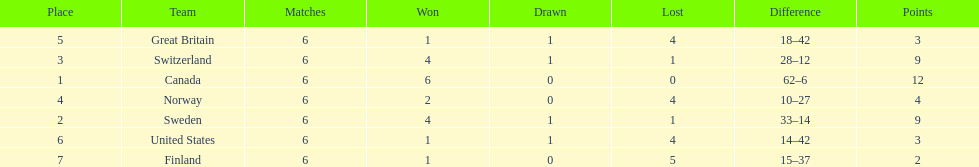Help me parse the entirety of this table. {'header': ['Place', 'Team', 'Matches', 'Won', 'Drawn', 'Lost', 'Difference', 'Points'], 'rows': [['5', 'Great Britain', '6', '1', '1', '4', '18–42', '3'], ['3', 'Switzerland', '6', '4', '1', '1', '28–12', '9'], ['1', 'Canada', '6', '6', '0', '0', '62–6', '12'], ['4', 'Norway', '6', '2', '0', '4', '10–27', '4'], ['2', 'Sweden', '6', '4', '1', '1', '33–14', '9'], ['6', 'United States', '6', '1', '1', '4', '14–42', '3'], ['7', 'Finland', '6', '1', '0', '5', '15–37', '2']]} What is the total number of teams to have 4 total wins? 2. 